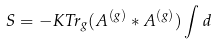Convert formula to latex. <formula><loc_0><loc_0><loc_500><loc_500>S = - K T r _ { g } ( A ^ { ( g ) } \ast A ^ { ( g ) } ) \int d</formula> 